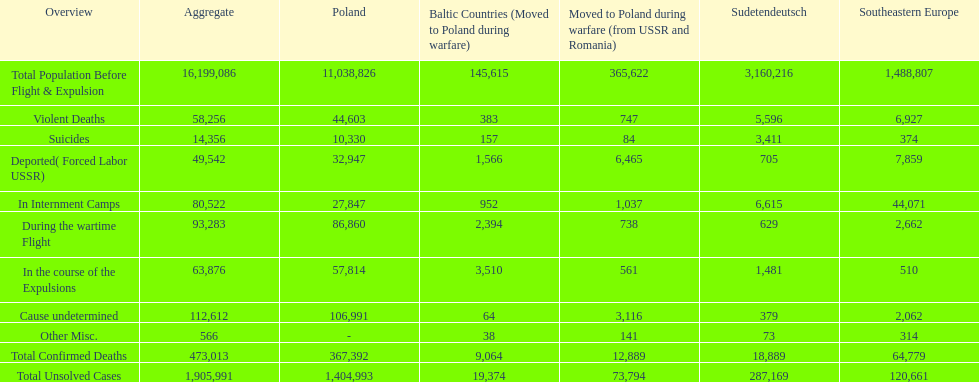What is the difference between suicides in poland and sudetendeutsch? 6919. 